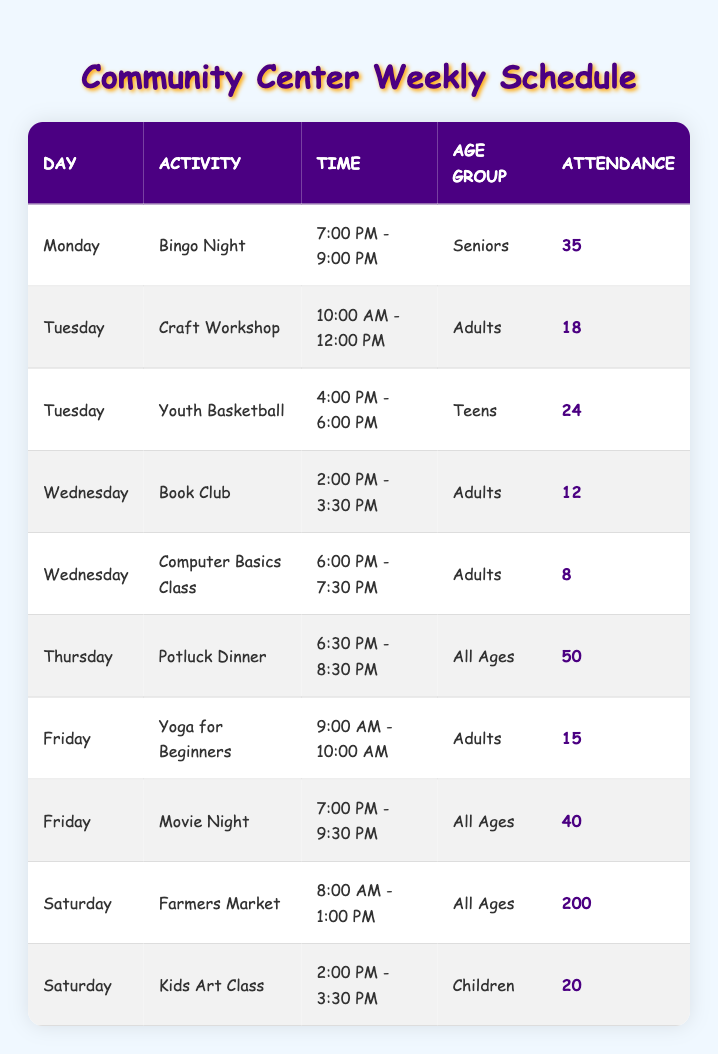What activity has the highest attendance? The table shows attendance numbers for each activity. To find the highest attendance, we look for the maximum value in the Attendance column. The Farmers Market on Saturday has the highest attendance with 200 participants.
Answer: Farmers Market How many adults attended the Yoga for Beginners class? To find the number of adults who attended the Yoga for Beginners class, we directly refer to the Attendance column of the corresponding row for this activity. The Yoga for Beginners class has 15 adults in attendance.
Answer: 15 True or False: There are more attendees at Bingo Night than in the Youth Basketball activity. We compare the attendance from the Bingo Night (35) and Youth Basketball (24). Since 35 is greater than 24, the statement is true.
Answer: True What is the total attendance for activities on Wednesday? We need to sum up the attendance figures for all Wednesday activities. The Book Club has 12 attendees, and the Computer Basics Class has 8 attendees. So, the total is 12 + 8 = 20.
Answer: 20 Which day has the most activities scheduled? We review the schedule for each day and count the activities. There are three activities on Tuesday and Saturday, while Monday, Wednesday, Thursday, and Friday have two activities each. Since Tuesday and Saturday are tied at three activities, we can say Saturday has the most activities specifically listed in this schedule.
Answer: Saturday What percentage of the Farmers Market's attendance is represented by the total attendance of all scheduled activities? The total attendance numbers are 200 (Farmers Market) + 35 + 18 + 24 + 12 + 8 + 50 + 15 + 40 + 20 = 422 total attendees in the week. To find the percentage, we calculate (200 / 422) * 100 = 47.4%.
Answer: 47.4% How many seniors attended activities throughout the week? The only activity listed for seniors is Bingo Night with 35 attendees. There are no other activities for seniors in the table, so the total count remains 35.
Answer: 35 How does the attendance of Movie Night compare to the attendance of the Craft Workshop? The attendance for Movie Night is 40, and for the Craft Workshop, it is 18. We compare these numbers directly and see that 40 is greater than 18, confirming Movie Night had higher attendance.
Answer: Higher What is the average attendance for all activities that involve adults? The activities for adults are the Craft Workshop (18), Book Club (12), Computer Basics Class (8), and Yoga for Beginners (15). We sum these (18 + 12 + 8 + 15 = 53) and divide by the number of adult activities (4), resulting in an average of 53/4 = 13.25.
Answer: 13.25 